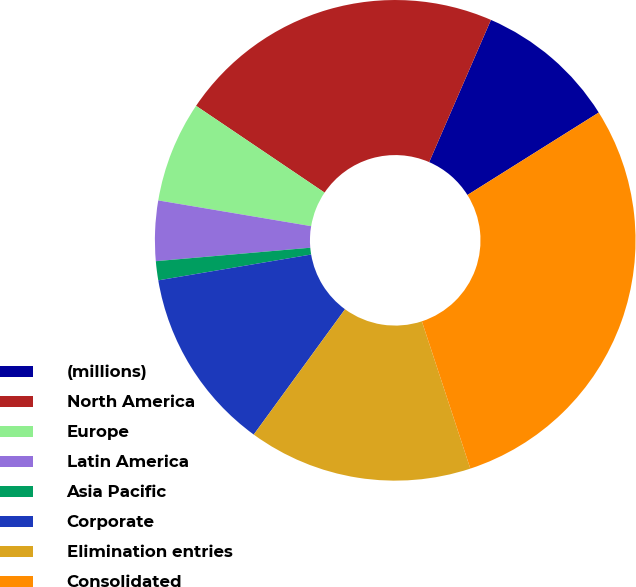Convert chart. <chart><loc_0><loc_0><loc_500><loc_500><pie_chart><fcel>(millions)<fcel>North America<fcel>Europe<fcel>Latin America<fcel>Asia Pacific<fcel>Corporate<fcel>Elimination entries<fcel>Consolidated<nl><fcel>9.56%<fcel>22.07%<fcel>6.8%<fcel>4.04%<fcel>1.28%<fcel>12.32%<fcel>15.08%<fcel>28.87%<nl></chart> 